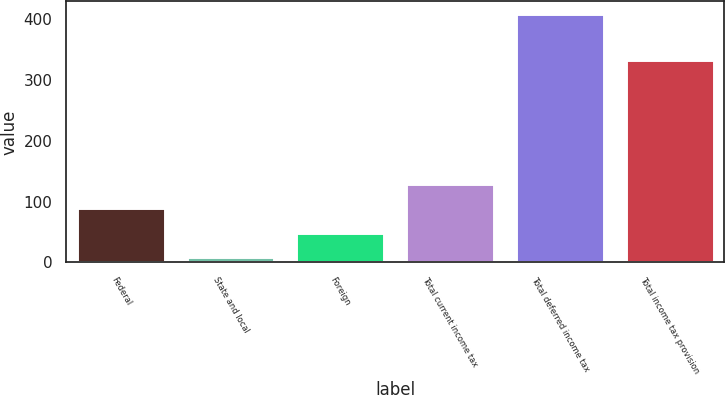Convert chart to OTSL. <chart><loc_0><loc_0><loc_500><loc_500><bar_chart><fcel>Federal<fcel>State and local<fcel>Foreign<fcel>Total current income tax<fcel>Total deferred income tax<fcel>Total income tax provision<nl><fcel>89<fcel>9<fcel>49<fcel>129<fcel>409<fcel>333<nl></chart> 